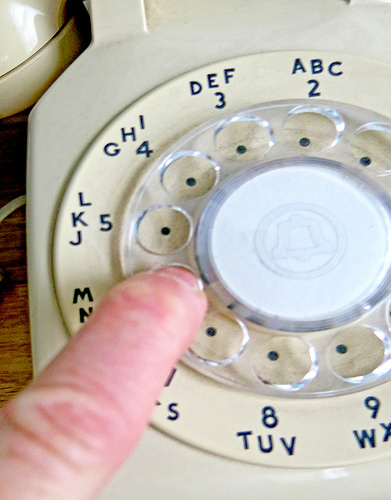<image>
Can you confirm if the finger is on the phone? Yes. Looking at the image, I can see the finger is positioned on top of the phone, with the phone providing support. 